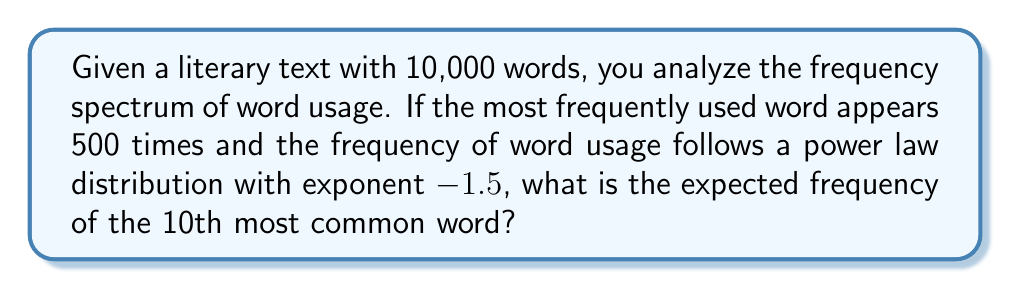Can you solve this math problem? To solve this problem, we'll use the power law distribution and the given information:

1. The power law distribution is given by:
   $$f(k) = C k^{-\alpha}$$
   where $f(k)$ is the frequency of the $k$-th ranked word, $C$ is a constant, and $\alpha$ is the exponent.

2. We're given that $\alpha = 1.5$ and $f(1) = 500$ (the most frequent word appears 500 times).

3. Let's find the constant $C$:
   $$500 = C \cdot 1^{-1.5}$$
   $$C = 500$$

4. Now we can write the full equation:
   $$f(k) = 500 k^{-1.5}$$

5. To find the frequency of the 10th most common word, we substitute $k = 10$:
   $$f(10) = 500 \cdot 10^{-1.5}$$

6. Calculate the result:
   $$f(10) = 500 \cdot 10^{-1.5} = 500 \cdot 0.0316227766 \approx 15.81$$

7. Since we're dealing with word frequencies, we need to round to the nearest whole number.
Answer: 16 